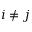Convert formula to latex. <formula><loc_0><loc_0><loc_500><loc_500>i \neq j</formula> 